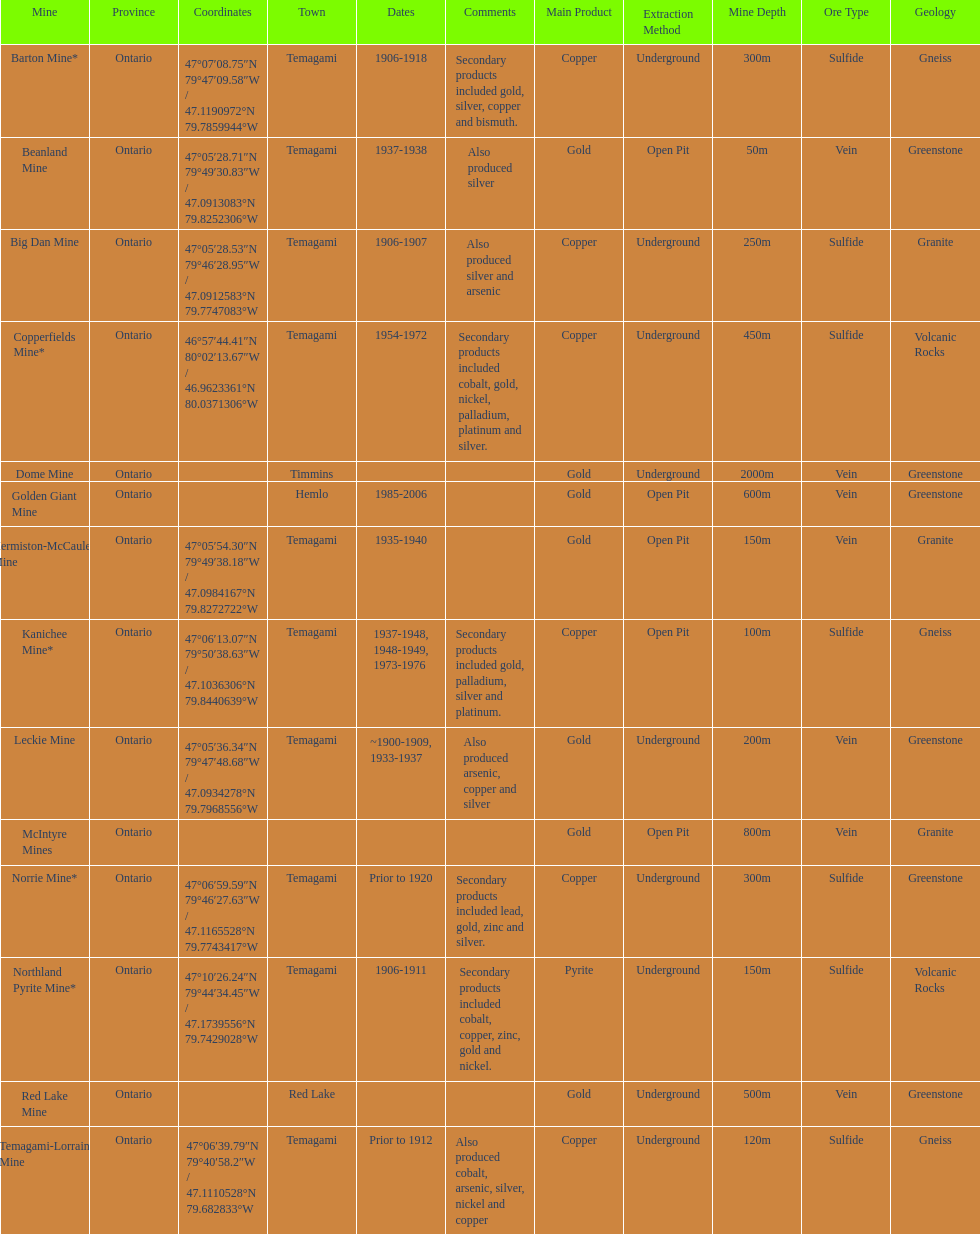How many mines were in temagami? 10. 